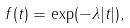Convert formula to latex. <formula><loc_0><loc_0><loc_500><loc_500>f ( t ) = \exp ( - \lambda | t | ) ,</formula> 